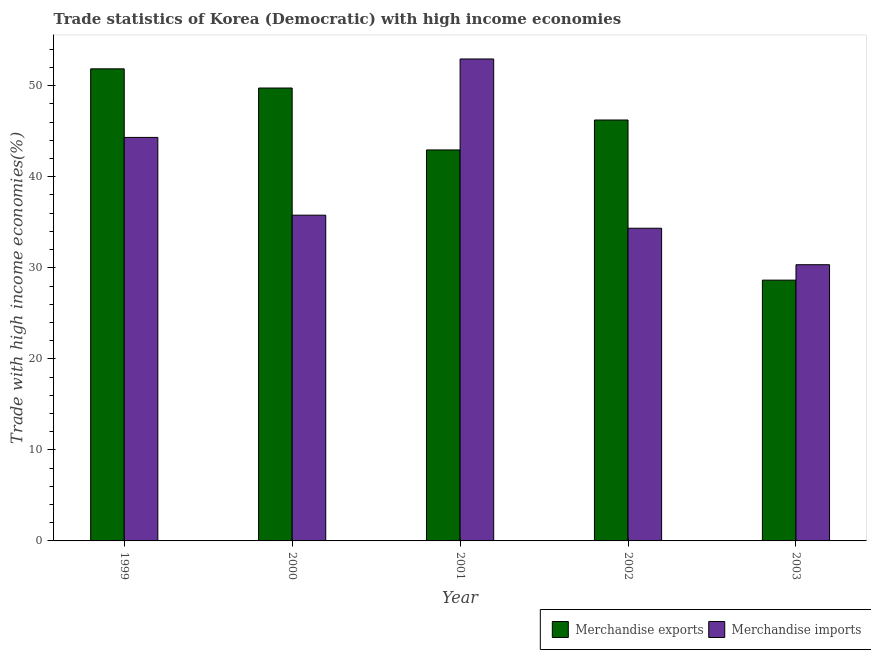Are the number of bars on each tick of the X-axis equal?
Make the answer very short. Yes. How many bars are there on the 1st tick from the left?
Provide a succinct answer. 2. How many bars are there on the 4th tick from the right?
Your answer should be compact. 2. What is the merchandise imports in 1999?
Offer a terse response. 44.32. Across all years, what is the maximum merchandise exports?
Give a very brief answer. 51.86. Across all years, what is the minimum merchandise imports?
Give a very brief answer. 30.34. In which year was the merchandise imports maximum?
Your answer should be very brief. 2001. In which year was the merchandise imports minimum?
Keep it short and to the point. 2003. What is the total merchandise imports in the graph?
Give a very brief answer. 197.74. What is the difference between the merchandise exports in 1999 and that in 2002?
Make the answer very short. 5.62. What is the difference between the merchandise imports in 2001 and the merchandise exports in 2002?
Offer a terse response. 18.59. What is the average merchandise exports per year?
Offer a terse response. 43.89. What is the ratio of the merchandise exports in 2000 to that in 2002?
Ensure brevity in your answer.  1.08. Is the difference between the merchandise imports in 2000 and 2001 greater than the difference between the merchandise exports in 2000 and 2001?
Your answer should be very brief. No. What is the difference between the highest and the second highest merchandise imports?
Offer a terse response. 8.62. What is the difference between the highest and the lowest merchandise imports?
Give a very brief answer. 22.6. Is the sum of the merchandise exports in 1999 and 2000 greater than the maximum merchandise imports across all years?
Offer a very short reply. Yes. What does the 2nd bar from the left in 2001 represents?
Offer a very short reply. Merchandise imports. How many bars are there?
Make the answer very short. 10. Are all the bars in the graph horizontal?
Ensure brevity in your answer.  No. What is the difference between two consecutive major ticks on the Y-axis?
Keep it short and to the point. 10. Are the values on the major ticks of Y-axis written in scientific E-notation?
Provide a short and direct response. No. Does the graph contain any zero values?
Offer a terse response. No. What is the title of the graph?
Your response must be concise. Trade statistics of Korea (Democratic) with high income economies. Does "Food" appear as one of the legend labels in the graph?
Your response must be concise. No. What is the label or title of the Y-axis?
Provide a short and direct response. Trade with high income economies(%). What is the Trade with high income economies(%) in Merchandise exports in 1999?
Make the answer very short. 51.86. What is the Trade with high income economies(%) in Merchandise imports in 1999?
Give a very brief answer. 44.32. What is the Trade with high income economies(%) of Merchandise exports in 2000?
Provide a succinct answer. 49.75. What is the Trade with high income economies(%) of Merchandise imports in 2000?
Offer a terse response. 35.78. What is the Trade with high income economies(%) in Merchandise exports in 2001?
Your response must be concise. 42.95. What is the Trade with high income economies(%) in Merchandise imports in 2001?
Give a very brief answer. 52.94. What is the Trade with high income economies(%) of Merchandise exports in 2002?
Your answer should be compact. 46.24. What is the Trade with high income economies(%) of Merchandise imports in 2002?
Provide a succinct answer. 34.35. What is the Trade with high income economies(%) of Merchandise exports in 2003?
Offer a terse response. 28.65. What is the Trade with high income economies(%) in Merchandise imports in 2003?
Make the answer very short. 30.34. Across all years, what is the maximum Trade with high income economies(%) in Merchandise exports?
Your answer should be very brief. 51.86. Across all years, what is the maximum Trade with high income economies(%) in Merchandise imports?
Provide a succinct answer. 52.94. Across all years, what is the minimum Trade with high income economies(%) in Merchandise exports?
Provide a short and direct response. 28.65. Across all years, what is the minimum Trade with high income economies(%) in Merchandise imports?
Provide a short and direct response. 30.34. What is the total Trade with high income economies(%) in Merchandise exports in the graph?
Ensure brevity in your answer.  219.45. What is the total Trade with high income economies(%) in Merchandise imports in the graph?
Ensure brevity in your answer.  197.74. What is the difference between the Trade with high income economies(%) in Merchandise exports in 1999 and that in 2000?
Give a very brief answer. 2.11. What is the difference between the Trade with high income economies(%) in Merchandise imports in 1999 and that in 2000?
Your answer should be very brief. 8.54. What is the difference between the Trade with high income economies(%) of Merchandise exports in 1999 and that in 2001?
Your answer should be very brief. 8.91. What is the difference between the Trade with high income economies(%) of Merchandise imports in 1999 and that in 2001?
Provide a short and direct response. -8.62. What is the difference between the Trade with high income economies(%) of Merchandise exports in 1999 and that in 2002?
Make the answer very short. 5.62. What is the difference between the Trade with high income economies(%) in Merchandise imports in 1999 and that in 2002?
Keep it short and to the point. 9.98. What is the difference between the Trade with high income economies(%) in Merchandise exports in 1999 and that in 2003?
Keep it short and to the point. 23.21. What is the difference between the Trade with high income economies(%) of Merchandise imports in 1999 and that in 2003?
Your answer should be compact. 13.98. What is the difference between the Trade with high income economies(%) of Merchandise exports in 2000 and that in 2001?
Your answer should be very brief. 6.8. What is the difference between the Trade with high income economies(%) in Merchandise imports in 2000 and that in 2001?
Keep it short and to the point. -17.16. What is the difference between the Trade with high income economies(%) of Merchandise exports in 2000 and that in 2002?
Your answer should be compact. 3.51. What is the difference between the Trade with high income economies(%) in Merchandise imports in 2000 and that in 2002?
Give a very brief answer. 1.44. What is the difference between the Trade with high income economies(%) of Merchandise exports in 2000 and that in 2003?
Ensure brevity in your answer.  21.1. What is the difference between the Trade with high income economies(%) in Merchandise imports in 2000 and that in 2003?
Ensure brevity in your answer.  5.44. What is the difference between the Trade with high income economies(%) of Merchandise exports in 2001 and that in 2002?
Give a very brief answer. -3.29. What is the difference between the Trade with high income economies(%) in Merchandise imports in 2001 and that in 2002?
Ensure brevity in your answer.  18.59. What is the difference between the Trade with high income economies(%) in Merchandise exports in 2001 and that in 2003?
Your response must be concise. 14.3. What is the difference between the Trade with high income economies(%) in Merchandise imports in 2001 and that in 2003?
Your response must be concise. 22.6. What is the difference between the Trade with high income economies(%) in Merchandise exports in 2002 and that in 2003?
Offer a very short reply. 17.59. What is the difference between the Trade with high income economies(%) of Merchandise imports in 2002 and that in 2003?
Give a very brief answer. 4.01. What is the difference between the Trade with high income economies(%) in Merchandise exports in 1999 and the Trade with high income economies(%) in Merchandise imports in 2000?
Your answer should be compact. 16.08. What is the difference between the Trade with high income economies(%) of Merchandise exports in 1999 and the Trade with high income economies(%) of Merchandise imports in 2001?
Keep it short and to the point. -1.08. What is the difference between the Trade with high income economies(%) in Merchandise exports in 1999 and the Trade with high income economies(%) in Merchandise imports in 2002?
Offer a terse response. 17.51. What is the difference between the Trade with high income economies(%) of Merchandise exports in 1999 and the Trade with high income economies(%) of Merchandise imports in 2003?
Provide a short and direct response. 21.52. What is the difference between the Trade with high income economies(%) of Merchandise exports in 2000 and the Trade with high income economies(%) of Merchandise imports in 2001?
Keep it short and to the point. -3.19. What is the difference between the Trade with high income economies(%) of Merchandise exports in 2000 and the Trade with high income economies(%) of Merchandise imports in 2002?
Make the answer very short. 15.4. What is the difference between the Trade with high income economies(%) in Merchandise exports in 2000 and the Trade with high income economies(%) in Merchandise imports in 2003?
Your answer should be compact. 19.41. What is the difference between the Trade with high income economies(%) in Merchandise exports in 2001 and the Trade with high income economies(%) in Merchandise imports in 2002?
Offer a terse response. 8.6. What is the difference between the Trade with high income economies(%) of Merchandise exports in 2001 and the Trade with high income economies(%) of Merchandise imports in 2003?
Offer a terse response. 12.61. What is the difference between the Trade with high income economies(%) of Merchandise exports in 2002 and the Trade with high income economies(%) of Merchandise imports in 2003?
Give a very brief answer. 15.9. What is the average Trade with high income economies(%) of Merchandise exports per year?
Give a very brief answer. 43.89. What is the average Trade with high income economies(%) in Merchandise imports per year?
Offer a very short reply. 39.55. In the year 1999, what is the difference between the Trade with high income economies(%) of Merchandise exports and Trade with high income economies(%) of Merchandise imports?
Keep it short and to the point. 7.53. In the year 2000, what is the difference between the Trade with high income economies(%) in Merchandise exports and Trade with high income economies(%) in Merchandise imports?
Your answer should be very brief. 13.97. In the year 2001, what is the difference between the Trade with high income economies(%) in Merchandise exports and Trade with high income economies(%) in Merchandise imports?
Your answer should be very brief. -9.99. In the year 2002, what is the difference between the Trade with high income economies(%) in Merchandise exports and Trade with high income economies(%) in Merchandise imports?
Offer a very short reply. 11.89. In the year 2003, what is the difference between the Trade with high income economies(%) in Merchandise exports and Trade with high income economies(%) in Merchandise imports?
Provide a succinct answer. -1.69. What is the ratio of the Trade with high income economies(%) of Merchandise exports in 1999 to that in 2000?
Provide a succinct answer. 1.04. What is the ratio of the Trade with high income economies(%) in Merchandise imports in 1999 to that in 2000?
Your answer should be compact. 1.24. What is the ratio of the Trade with high income economies(%) in Merchandise exports in 1999 to that in 2001?
Your response must be concise. 1.21. What is the ratio of the Trade with high income economies(%) in Merchandise imports in 1999 to that in 2001?
Provide a succinct answer. 0.84. What is the ratio of the Trade with high income economies(%) in Merchandise exports in 1999 to that in 2002?
Your response must be concise. 1.12. What is the ratio of the Trade with high income economies(%) of Merchandise imports in 1999 to that in 2002?
Provide a succinct answer. 1.29. What is the ratio of the Trade with high income economies(%) in Merchandise exports in 1999 to that in 2003?
Your answer should be compact. 1.81. What is the ratio of the Trade with high income economies(%) in Merchandise imports in 1999 to that in 2003?
Keep it short and to the point. 1.46. What is the ratio of the Trade with high income economies(%) in Merchandise exports in 2000 to that in 2001?
Your response must be concise. 1.16. What is the ratio of the Trade with high income economies(%) in Merchandise imports in 2000 to that in 2001?
Provide a succinct answer. 0.68. What is the ratio of the Trade with high income economies(%) in Merchandise exports in 2000 to that in 2002?
Your answer should be very brief. 1.08. What is the ratio of the Trade with high income economies(%) of Merchandise imports in 2000 to that in 2002?
Provide a short and direct response. 1.04. What is the ratio of the Trade with high income economies(%) in Merchandise exports in 2000 to that in 2003?
Your answer should be very brief. 1.74. What is the ratio of the Trade with high income economies(%) in Merchandise imports in 2000 to that in 2003?
Your response must be concise. 1.18. What is the ratio of the Trade with high income economies(%) of Merchandise exports in 2001 to that in 2002?
Your response must be concise. 0.93. What is the ratio of the Trade with high income economies(%) in Merchandise imports in 2001 to that in 2002?
Make the answer very short. 1.54. What is the ratio of the Trade with high income economies(%) in Merchandise exports in 2001 to that in 2003?
Provide a short and direct response. 1.5. What is the ratio of the Trade with high income economies(%) of Merchandise imports in 2001 to that in 2003?
Provide a succinct answer. 1.74. What is the ratio of the Trade with high income economies(%) of Merchandise exports in 2002 to that in 2003?
Your response must be concise. 1.61. What is the ratio of the Trade with high income economies(%) in Merchandise imports in 2002 to that in 2003?
Ensure brevity in your answer.  1.13. What is the difference between the highest and the second highest Trade with high income economies(%) of Merchandise exports?
Your answer should be compact. 2.11. What is the difference between the highest and the second highest Trade with high income economies(%) in Merchandise imports?
Provide a short and direct response. 8.62. What is the difference between the highest and the lowest Trade with high income economies(%) in Merchandise exports?
Offer a very short reply. 23.21. What is the difference between the highest and the lowest Trade with high income economies(%) in Merchandise imports?
Offer a terse response. 22.6. 